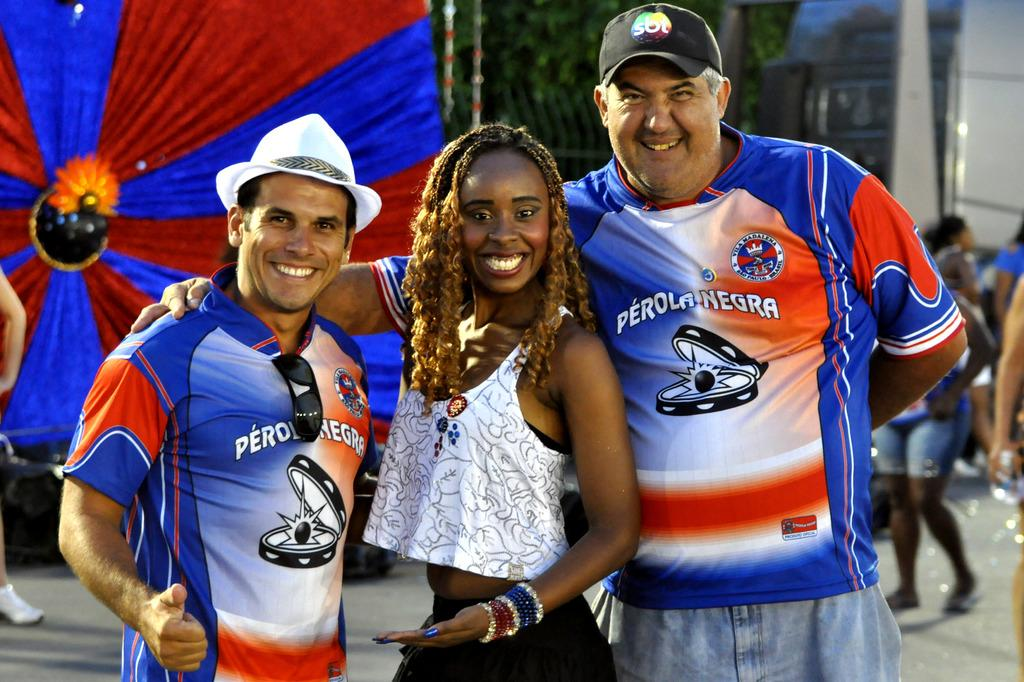Provide a one-sentence caption for the provided image. three people smiling at the camera with PERONEGRA on the men's shirts, the woman is just in between them both. 